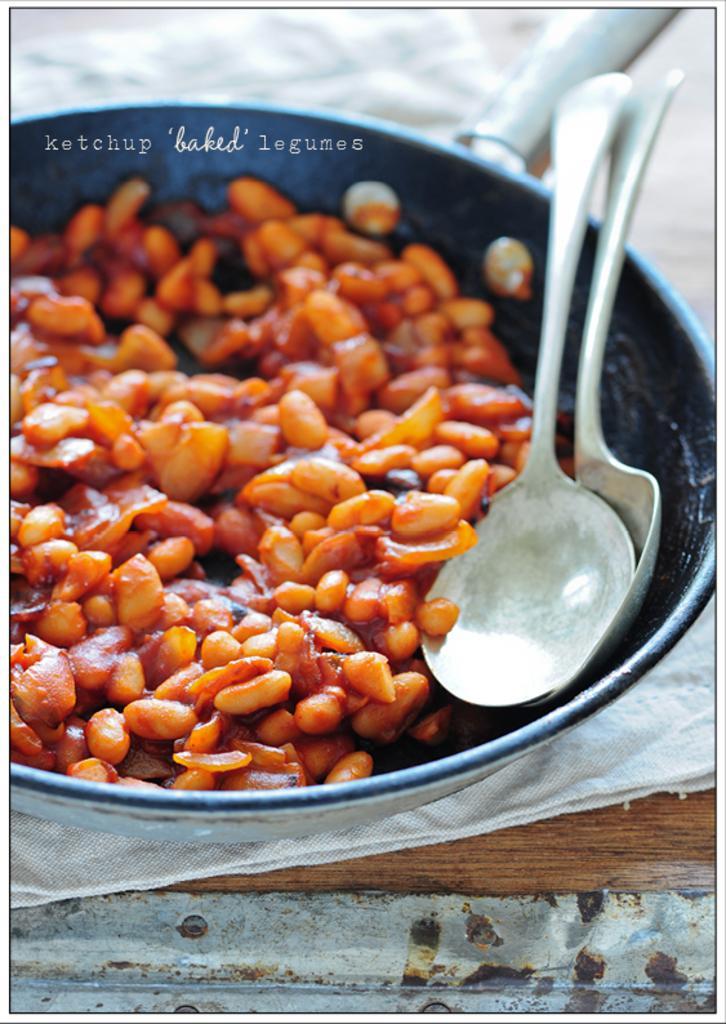Please provide a concise description of this image. In the image we can see there are peanuts and food item kept in the bowl. There are spoons kept on the bowl and the bowl is kept on the table. 